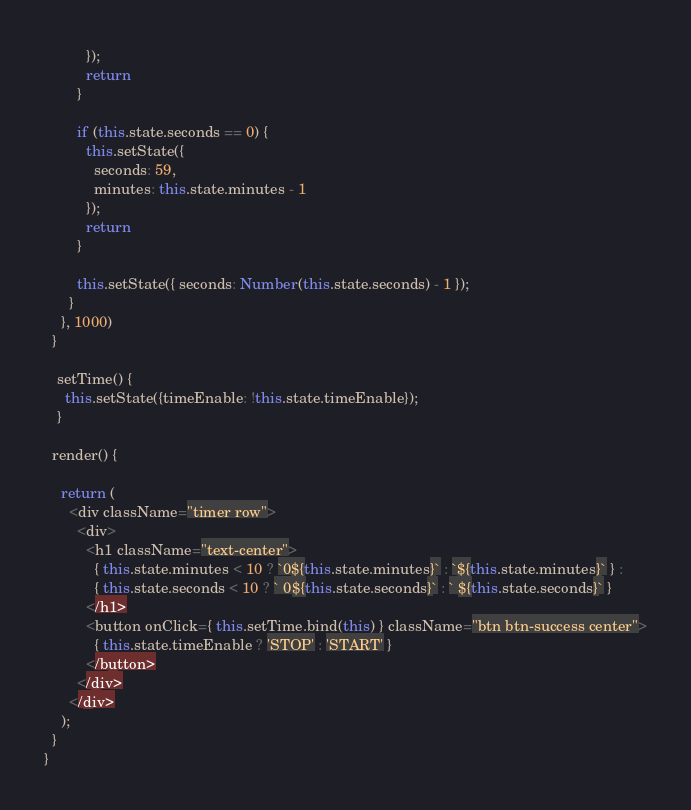Convert code to text. <code><loc_0><loc_0><loc_500><loc_500><_JavaScript_>          });
          return
        }

        if (this.state.seconds == 0) {
          this.setState({
            seconds: 59,
            minutes: this.state.minutes - 1
          });
          return
        }

        this.setState({ seconds: Number(this.state.seconds) - 1 });
      }
    }, 1000)
  }

   setTime() {
     this.setState({timeEnable: !this.state.timeEnable});
   }

  render() {

    return (
      <div className="timer row">
        <div>
          <h1 className="text-center">
            { this.state.minutes < 10 ? `0${this.state.minutes}` : `${this.state.minutes}` } :
            { this.state.seconds < 10 ? ` 0${this.state.seconds}` : ` ${this.state.seconds}` }
          </h1>
          <button onClick={ this.setTime.bind(this) } className="btn btn-success center">
            { this.state.timeEnable ? 'STOP' : 'START' }
          </button>
        </div>
      </div>
    );
  }
}
</code> 